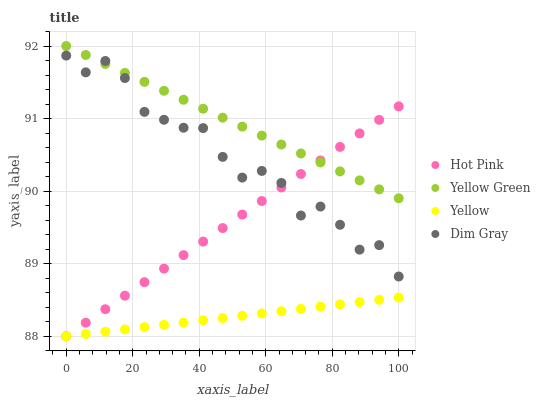Does Yellow have the minimum area under the curve?
Answer yes or no. Yes. Does Yellow Green have the maximum area under the curve?
Answer yes or no. Yes. Does Hot Pink have the minimum area under the curve?
Answer yes or no. No. Does Hot Pink have the maximum area under the curve?
Answer yes or no. No. Is Yellow Green the smoothest?
Answer yes or no. Yes. Is Dim Gray the roughest?
Answer yes or no. Yes. Is Hot Pink the smoothest?
Answer yes or no. No. Is Hot Pink the roughest?
Answer yes or no. No. Does Hot Pink have the lowest value?
Answer yes or no. Yes. Does Yellow Green have the lowest value?
Answer yes or no. No. Does Yellow Green have the highest value?
Answer yes or no. Yes. Does Hot Pink have the highest value?
Answer yes or no. No. Is Yellow less than Yellow Green?
Answer yes or no. Yes. Is Yellow Green greater than Yellow?
Answer yes or no. Yes. Does Yellow intersect Hot Pink?
Answer yes or no. Yes. Is Yellow less than Hot Pink?
Answer yes or no. No. Is Yellow greater than Hot Pink?
Answer yes or no. No. Does Yellow intersect Yellow Green?
Answer yes or no. No. 